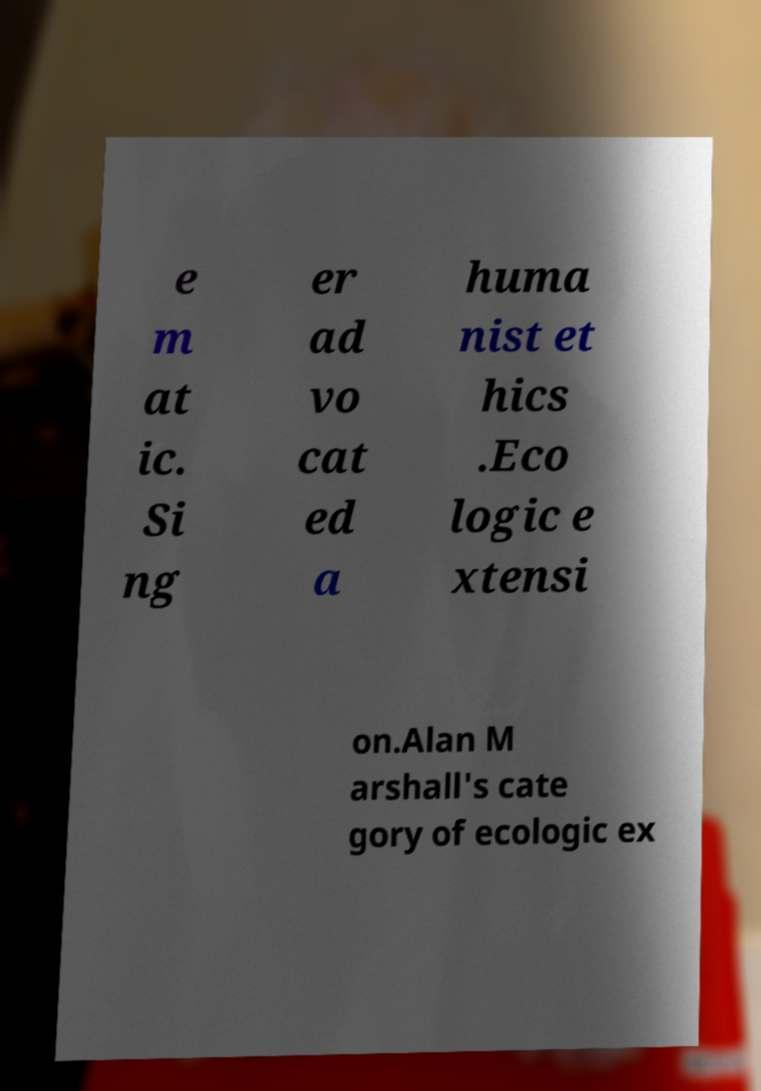I need the written content from this picture converted into text. Can you do that? e m at ic. Si ng er ad vo cat ed a huma nist et hics .Eco logic e xtensi on.Alan M arshall's cate gory of ecologic ex 